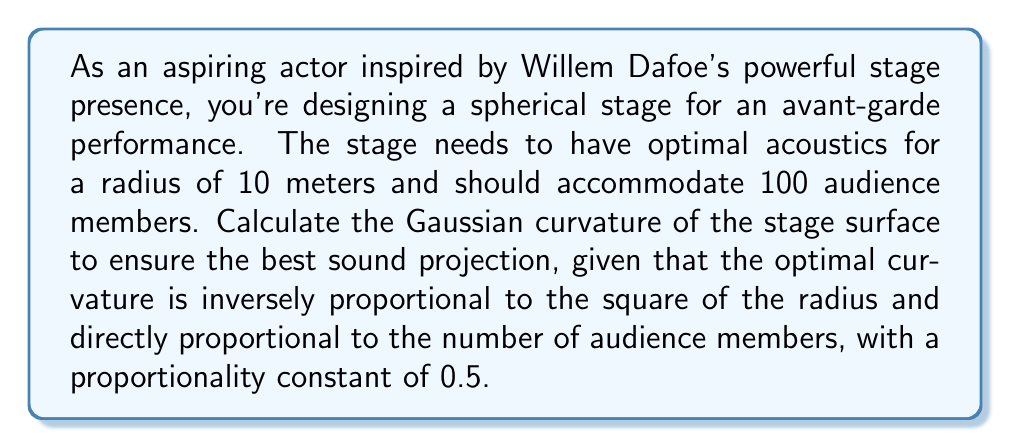Give your solution to this math problem. Let's approach this step-by-step:

1) The Gaussian curvature ($K$) of a sphere is constant over its entire surface and is given by:

   $$K = \frac{1}{R^2}$$

   where $R$ is the radius of the sphere.

2) However, in this case, we need to modify this formula to account for the number of audience members and the given proportionality constant. The new formula becomes:

   $$K = \frac{0.5 \cdot N}{R^2}$$

   where $N$ is the number of audience members and 0.5 is the proportionality constant.

3) We are given:
   - Radius ($R$) = 10 meters
   - Number of audience members ($N$) = 100
   - Proportionality constant = 0.5

4) Let's substitute these values into our formula:

   $$K = \frac{0.5 \cdot 100}{10^2}$$

5) Simplify:
   $$K = \frac{50}{100} = 0.5$$

Therefore, the Gaussian curvature of the stage surface for optimal acoustics is 0.5 m^(-2).
Answer: $0.5 \text{ m}^{-2}$ 